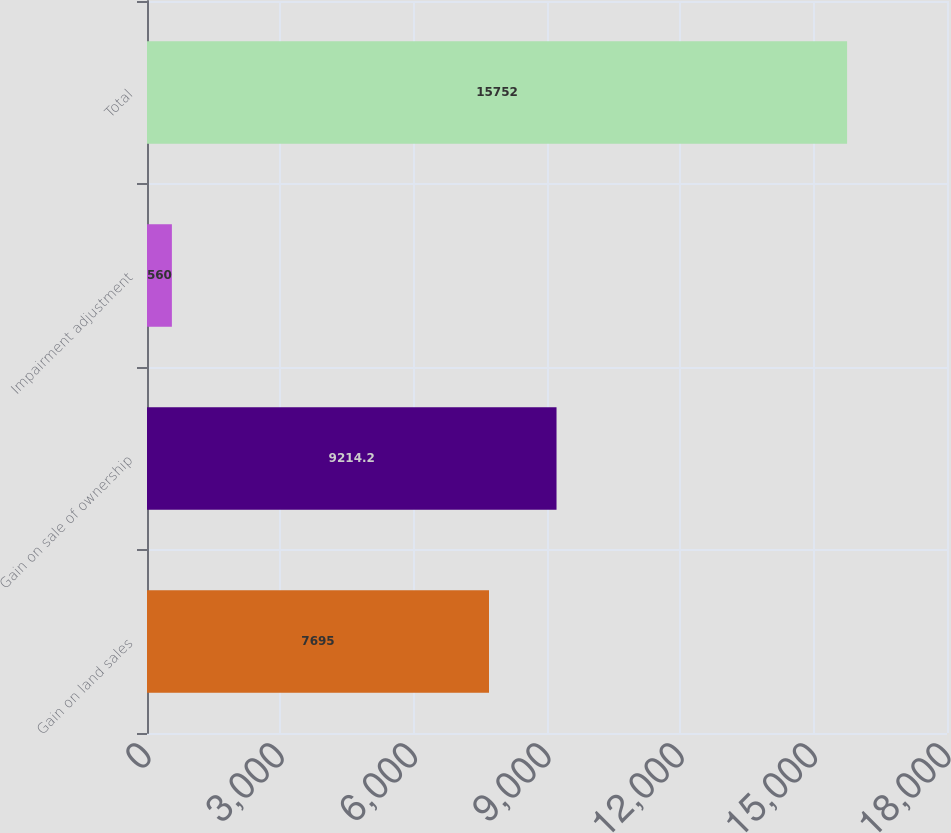<chart> <loc_0><loc_0><loc_500><loc_500><bar_chart><fcel>Gain on land sales<fcel>Gain on sale of ownership<fcel>Impairment adjustment<fcel>Total<nl><fcel>7695<fcel>9214.2<fcel>560<fcel>15752<nl></chart> 